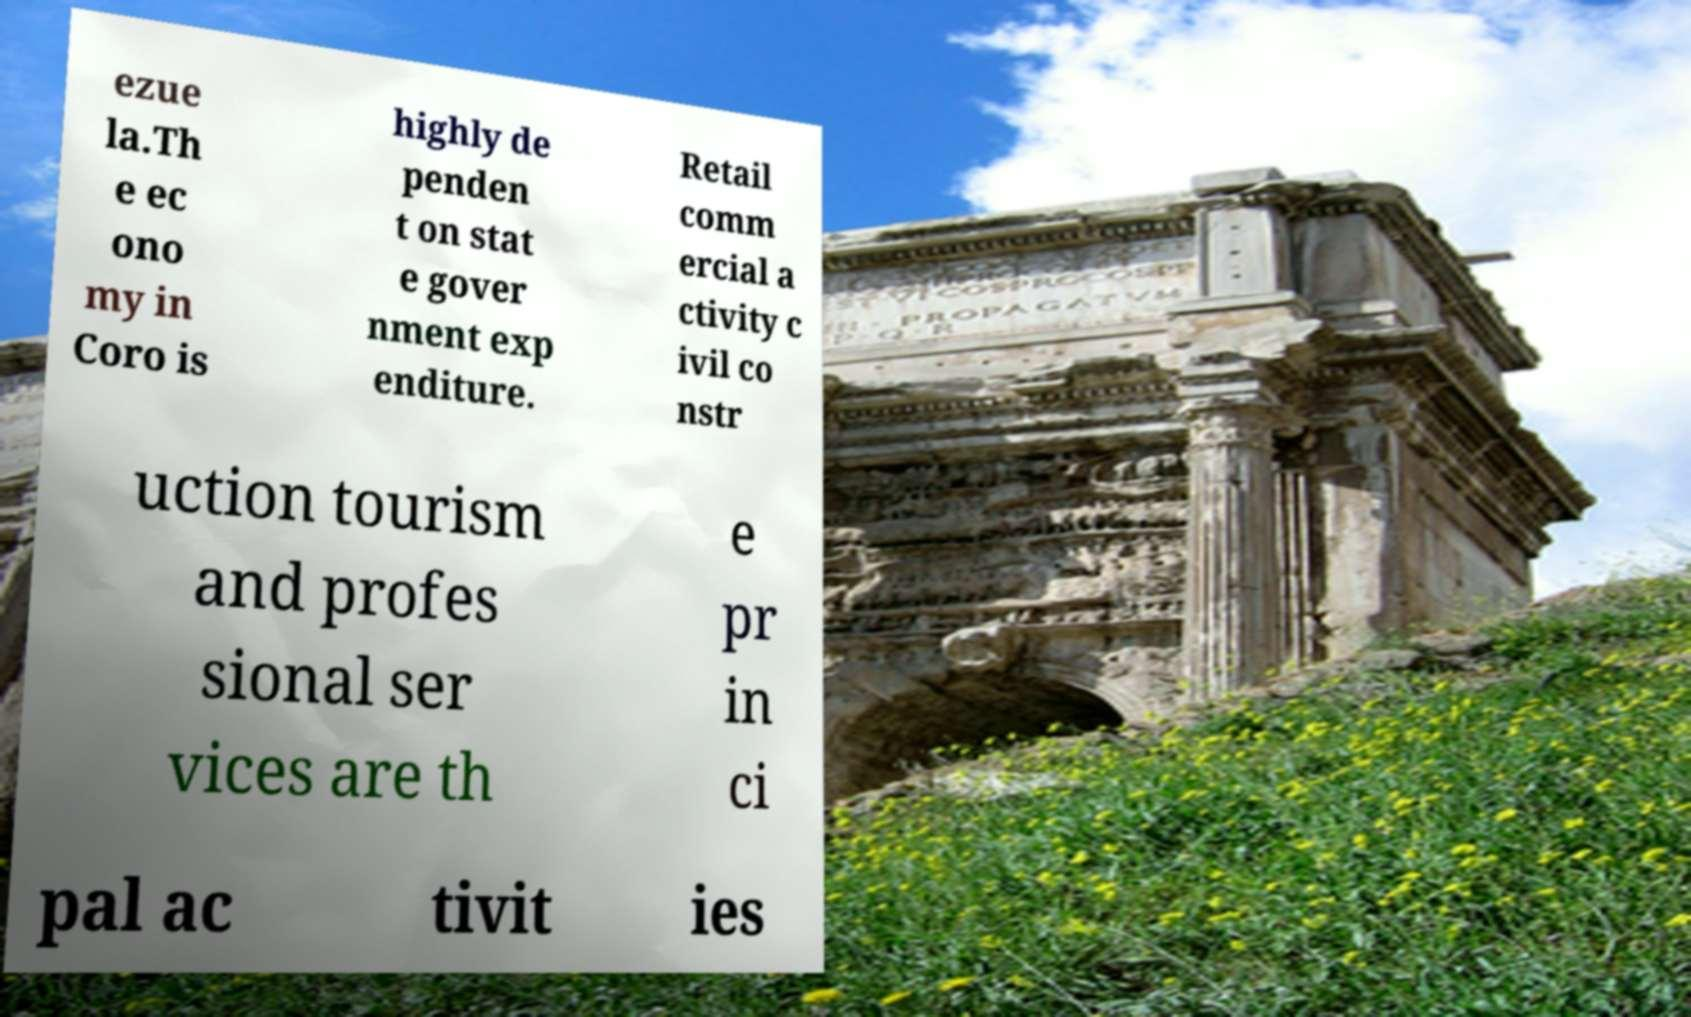Could you assist in decoding the text presented in this image and type it out clearly? ezue la.Th e ec ono my in Coro is highly de penden t on stat e gover nment exp enditure. Retail comm ercial a ctivity c ivil co nstr uction tourism and profes sional ser vices are th e pr in ci pal ac tivit ies 